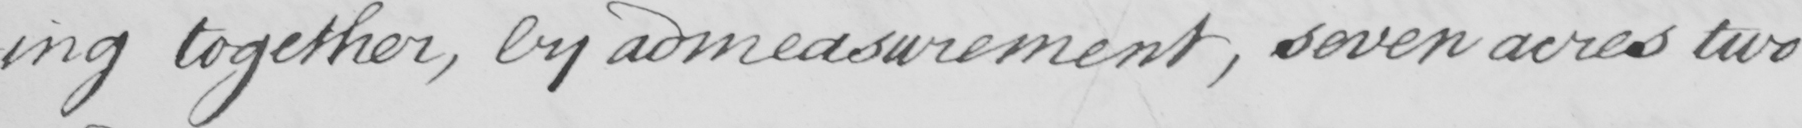Please provide the text content of this handwritten line. -ing together , by admeasurement , seven acres two 